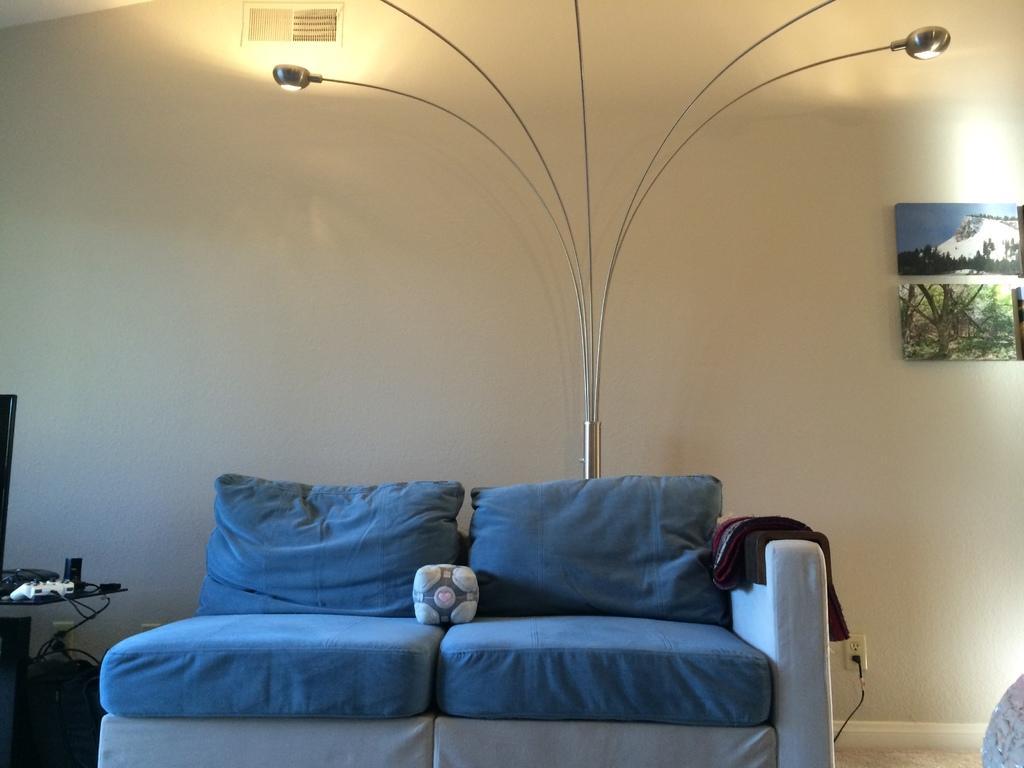Can you describe this image briefly? Here is a couch with blue color cushions on it,and this looks like a cloth which is placed on the couch. This is a lamp and I can see a poster attached to the wall. Here is a socket with cable attached. At the left corner of the image I can see a small table with a joystick and some objects placed on it. 